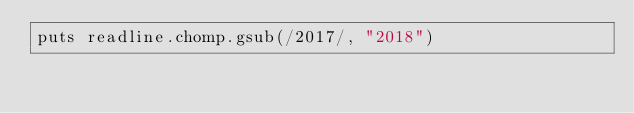Convert code to text. <code><loc_0><loc_0><loc_500><loc_500><_Ruby_>puts readline.chomp.gsub(/2017/, "2018")</code> 